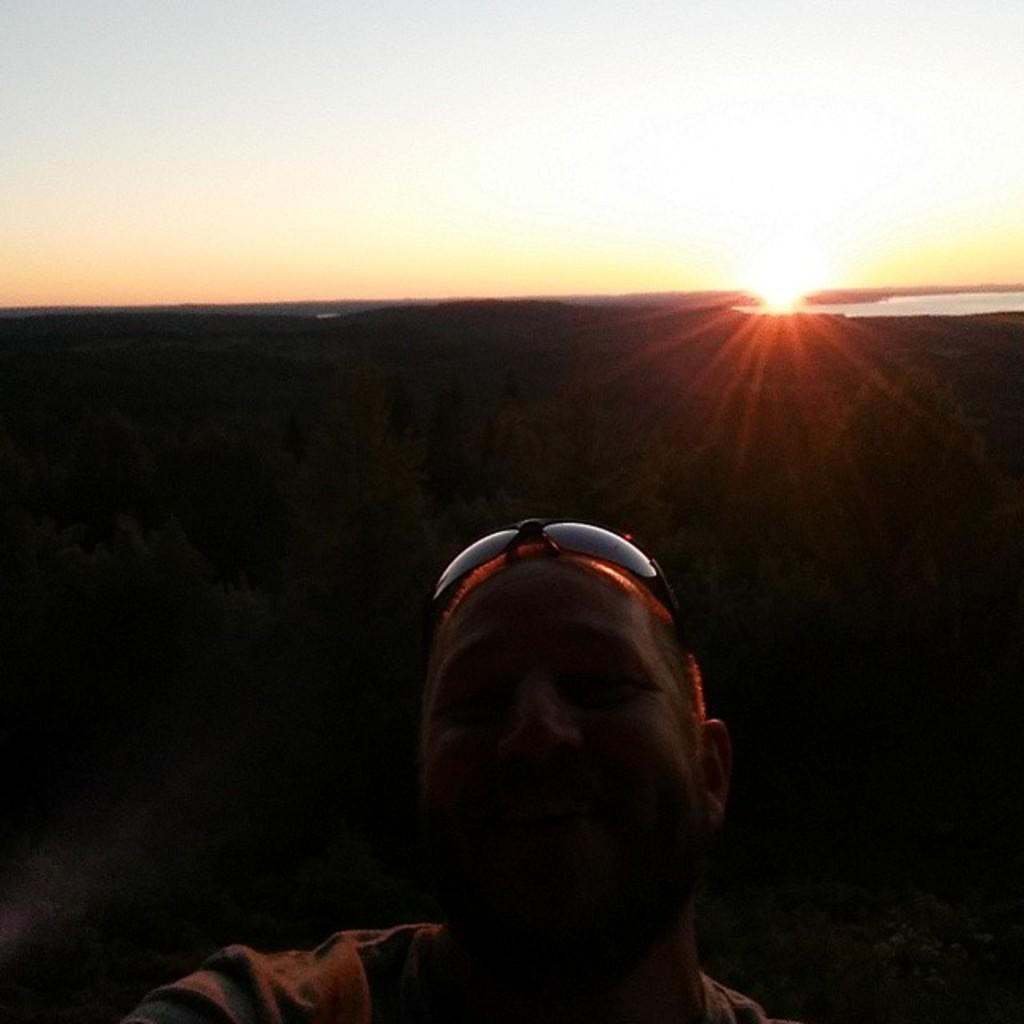What is located in the foreground of the image? There is a person in the foreground of the image. What can be seen in the background of the image? There are trees and water visible in the background of the image. What is the condition of the sky in the image? The sky is visible in the background of the image, and the sun is observable in the sky. What type of sidewalk can be seen in the image? There is no sidewalk present in the image. Can you describe the cub that is interacting with the person in the image? There is no cub present in the image; it only features a person and the background elements. 